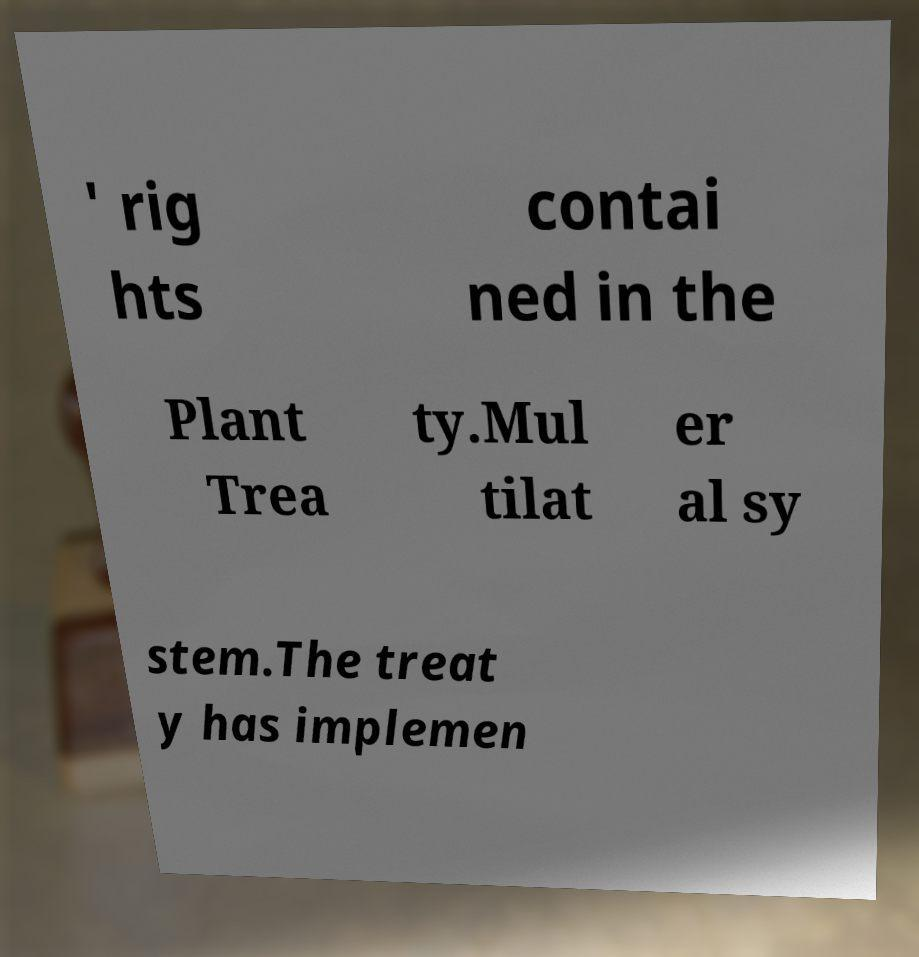Please read and relay the text visible in this image. What does it say? ' rig hts contai ned in the Plant Trea ty.Mul tilat er al sy stem.The treat y has implemen 